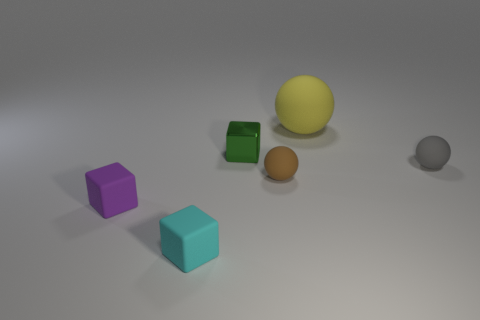Add 3 large yellow balls. How many objects exist? 9 Subtract all large rubber balls. How many balls are left? 2 Subtract 1 blocks. How many blocks are left? 2 Subtract all green cubes. How many cubes are left? 2 Subtract all big yellow shiny objects. Subtract all tiny gray matte balls. How many objects are left? 5 Add 3 tiny purple blocks. How many tiny purple blocks are left? 4 Add 2 metal cubes. How many metal cubes exist? 3 Subtract 0 yellow cubes. How many objects are left? 6 Subtract all green balls. Subtract all yellow blocks. How many balls are left? 3 Subtract all red cylinders. How many brown blocks are left? 0 